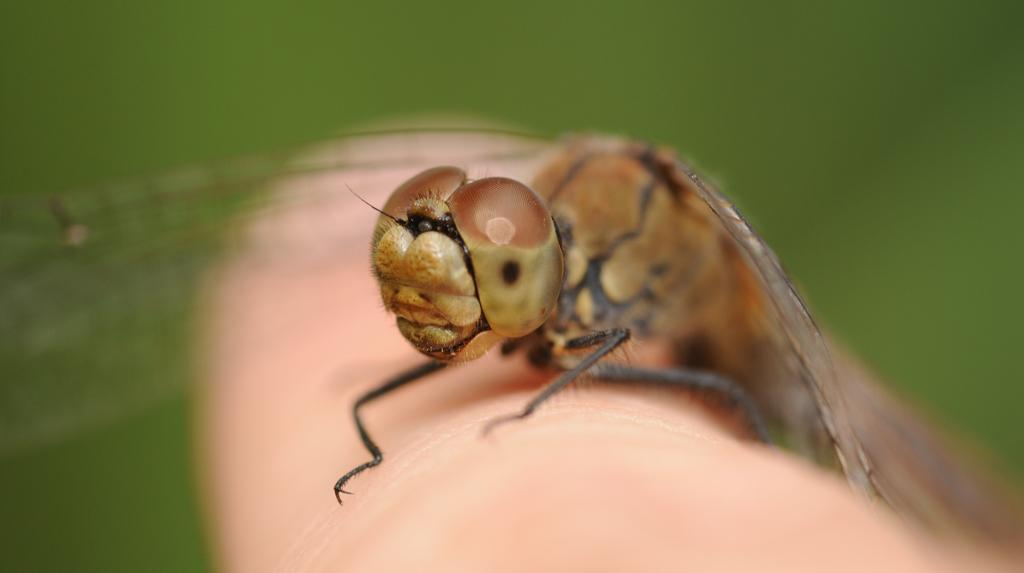What is present on the finger in the image? There is an insect on a finger in the image. Can you describe the insect in the image? Unfortunately, the provided facts do not include a description of the insect. What can be observed about the background of the image? The background of the image is blurred. What type of jam is being spread on the fish in the image? There is no fish or jam present in the image; it features an insect on a finger with a blurred background. 